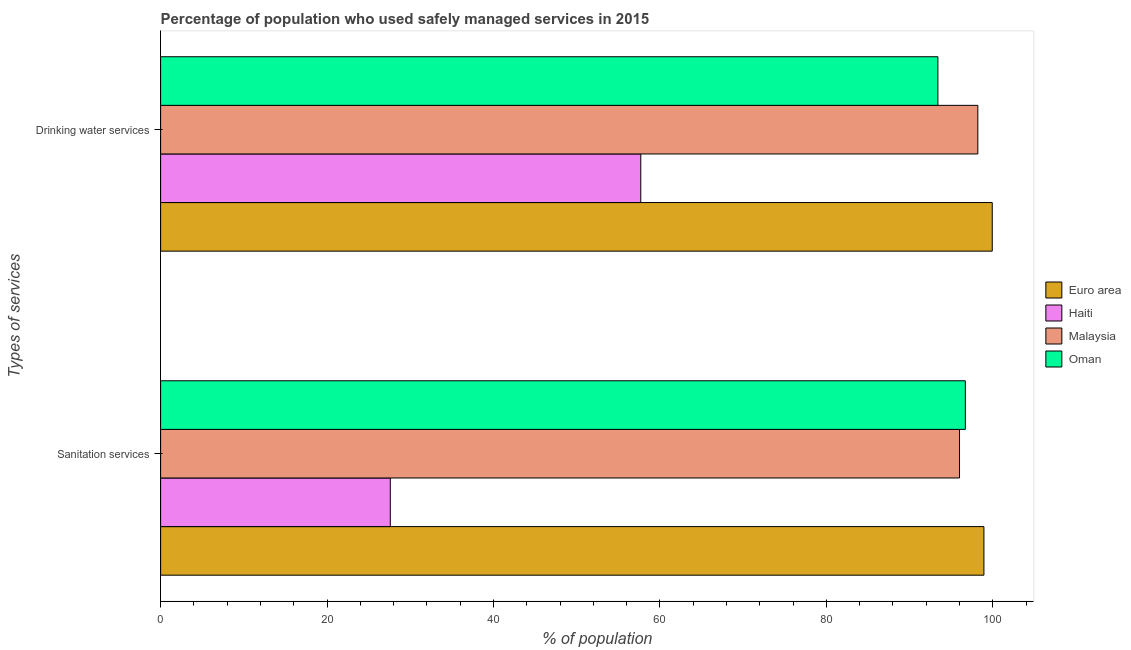How many different coloured bars are there?
Keep it short and to the point. 4. How many groups of bars are there?
Give a very brief answer. 2. Are the number of bars per tick equal to the number of legend labels?
Your response must be concise. Yes. Are the number of bars on each tick of the Y-axis equal?
Provide a succinct answer. Yes. What is the label of the 2nd group of bars from the top?
Offer a terse response. Sanitation services. What is the percentage of population who used sanitation services in Haiti?
Your answer should be compact. 27.6. Across all countries, what is the maximum percentage of population who used drinking water services?
Your answer should be compact. 99.93. Across all countries, what is the minimum percentage of population who used sanitation services?
Offer a terse response. 27.6. In which country was the percentage of population who used sanitation services minimum?
Offer a terse response. Haiti. What is the total percentage of population who used sanitation services in the graph?
Offer a terse response. 319.23. What is the difference between the percentage of population who used drinking water services in Malaysia and that in Haiti?
Keep it short and to the point. 40.5. What is the difference between the percentage of population who used sanitation services in Malaysia and the percentage of population who used drinking water services in Haiti?
Provide a short and direct response. 38.3. What is the average percentage of population who used drinking water services per country?
Provide a short and direct response. 87.31. What is the difference between the percentage of population who used sanitation services and percentage of population who used drinking water services in Oman?
Make the answer very short. 3.3. In how many countries, is the percentage of population who used sanitation services greater than 32 %?
Make the answer very short. 3. What is the ratio of the percentage of population who used drinking water services in Haiti to that in Malaysia?
Keep it short and to the point. 0.59. In how many countries, is the percentage of population who used sanitation services greater than the average percentage of population who used sanitation services taken over all countries?
Ensure brevity in your answer.  3. What does the 3rd bar from the top in Sanitation services represents?
Your answer should be very brief. Haiti. What does the 3rd bar from the bottom in Drinking water services represents?
Provide a succinct answer. Malaysia. How many countries are there in the graph?
Your response must be concise. 4. Are the values on the major ticks of X-axis written in scientific E-notation?
Provide a succinct answer. No. Does the graph contain grids?
Provide a short and direct response. No. Where does the legend appear in the graph?
Provide a succinct answer. Center right. How are the legend labels stacked?
Make the answer very short. Vertical. What is the title of the graph?
Offer a terse response. Percentage of population who used safely managed services in 2015. Does "Arab World" appear as one of the legend labels in the graph?
Your response must be concise. No. What is the label or title of the X-axis?
Ensure brevity in your answer.  % of population. What is the label or title of the Y-axis?
Provide a short and direct response. Types of services. What is the % of population in Euro area in Sanitation services?
Provide a short and direct response. 98.93. What is the % of population in Haiti in Sanitation services?
Ensure brevity in your answer.  27.6. What is the % of population of Malaysia in Sanitation services?
Your answer should be compact. 96. What is the % of population in Oman in Sanitation services?
Keep it short and to the point. 96.7. What is the % of population of Euro area in Drinking water services?
Provide a short and direct response. 99.93. What is the % of population in Haiti in Drinking water services?
Your response must be concise. 57.7. What is the % of population in Malaysia in Drinking water services?
Provide a succinct answer. 98.2. What is the % of population of Oman in Drinking water services?
Provide a succinct answer. 93.4. Across all Types of services, what is the maximum % of population in Euro area?
Give a very brief answer. 99.93. Across all Types of services, what is the maximum % of population in Haiti?
Offer a terse response. 57.7. Across all Types of services, what is the maximum % of population of Malaysia?
Make the answer very short. 98.2. Across all Types of services, what is the maximum % of population in Oman?
Your answer should be very brief. 96.7. Across all Types of services, what is the minimum % of population of Euro area?
Keep it short and to the point. 98.93. Across all Types of services, what is the minimum % of population of Haiti?
Offer a terse response. 27.6. Across all Types of services, what is the minimum % of population of Malaysia?
Give a very brief answer. 96. Across all Types of services, what is the minimum % of population of Oman?
Your response must be concise. 93.4. What is the total % of population of Euro area in the graph?
Make the answer very short. 198.87. What is the total % of population of Haiti in the graph?
Keep it short and to the point. 85.3. What is the total % of population in Malaysia in the graph?
Your answer should be compact. 194.2. What is the total % of population in Oman in the graph?
Make the answer very short. 190.1. What is the difference between the % of population in Euro area in Sanitation services and that in Drinking water services?
Make the answer very short. -1. What is the difference between the % of population of Haiti in Sanitation services and that in Drinking water services?
Your response must be concise. -30.1. What is the difference between the % of population in Euro area in Sanitation services and the % of population in Haiti in Drinking water services?
Provide a succinct answer. 41.23. What is the difference between the % of population of Euro area in Sanitation services and the % of population of Malaysia in Drinking water services?
Provide a succinct answer. 0.73. What is the difference between the % of population of Euro area in Sanitation services and the % of population of Oman in Drinking water services?
Provide a short and direct response. 5.53. What is the difference between the % of population of Haiti in Sanitation services and the % of population of Malaysia in Drinking water services?
Your answer should be very brief. -70.6. What is the difference between the % of population of Haiti in Sanitation services and the % of population of Oman in Drinking water services?
Provide a succinct answer. -65.8. What is the average % of population in Euro area per Types of services?
Keep it short and to the point. 99.43. What is the average % of population of Haiti per Types of services?
Offer a very short reply. 42.65. What is the average % of population in Malaysia per Types of services?
Make the answer very short. 97.1. What is the average % of population in Oman per Types of services?
Your response must be concise. 95.05. What is the difference between the % of population in Euro area and % of population in Haiti in Sanitation services?
Your response must be concise. 71.33. What is the difference between the % of population of Euro area and % of population of Malaysia in Sanitation services?
Make the answer very short. 2.93. What is the difference between the % of population in Euro area and % of population in Oman in Sanitation services?
Give a very brief answer. 2.23. What is the difference between the % of population of Haiti and % of population of Malaysia in Sanitation services?
Make the answer very short. -68.4. What is the difference between the % of population in Haiti and % of population in Oman in Sanitation services?
Keep it short and to the point. -69.1. What is the difference between the % of population in Malaysia and % of population in Oman in Sanitation services?
Keep it short and to the point. -0.7. What is the difference between the % of population in Euro area and % of population in Haiti in Drinking water services?
Offer a terse response. 42.23. What is the difference between the % of population in Euro area and % of population in Malaysia in Drinking water services?
Ensure brevity in your answer.  1.73. What is the difference between the % of population of Euro area and % of population of Oman in Drinking water services?
Keep it short and to the point. 6.53. What is the difference between the % of population in Haiti and % of population in Malaysia in Drinking water services?
Offer a terse response. -40.5. What is the difference between the % of population of Haiti and % of population of Oman in Drinking water services?
Make the answer very short. -35.7. What is the ratio of the % of population in Euro area in Sanitation services to that in Drinking water services?
Offer a terse response. 0.99. What is the ratio of the % of population of Haiti in Sanitation services to that in Drinking water services?
Offer a very short reply. 0.48. What is the ratio of the % of population of Malaysia in Sanitation services to that in Drinking water services?
Offer a terse response. 0.98. What is the ratio of the % of population in Oman in Sanitation services to that in Drinking water services?
Offer a terse response. 1.04. What is the difference between the highest and the second highest % of population in Haiti?
Make the answer very short. 30.1. What is the difference between the highest and the second highest % of population of Oman?
Ensure brevity in your answer.  3.3. What is the difference between the highest and the lowest % of population of Haiti?
Offer a very short reply. 30.1. What is the difference between the highest and the lowest % of population in Malaysia?
Offer a very short reply. 2.2. What is the difference between the highest and the lowest % of population of Oman?
Your answer should be compact. 3.3. 